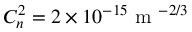<formula> <loc_0><loc_0><loc_500><loc_500>C _ { n } ^ { 2 } = 2 \times 1 0 ^ { - 1 5 } m ^ { - 2 / 3 }</formula> 